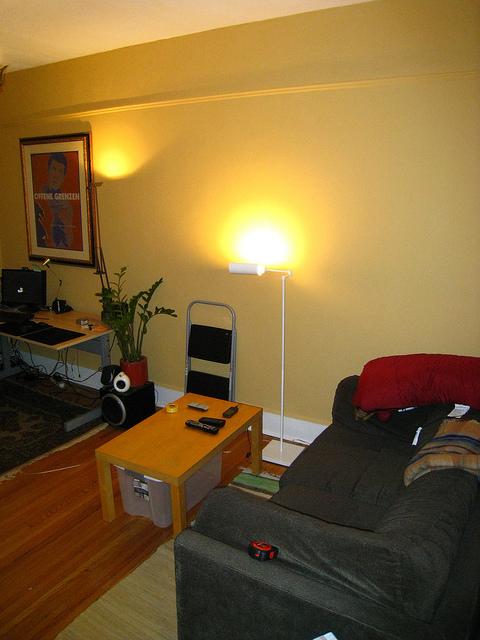Is there a toy car on the arm of the couch?
Quick response, please. Yes. Where is the bed?
Answer briefly. Not shown. Are lights turned on in this room?
Quick response, please. Yes. Where are the remote controls?
Keep it brief. On table. What color is the wall?
Give a very brief answer. Yellow. 